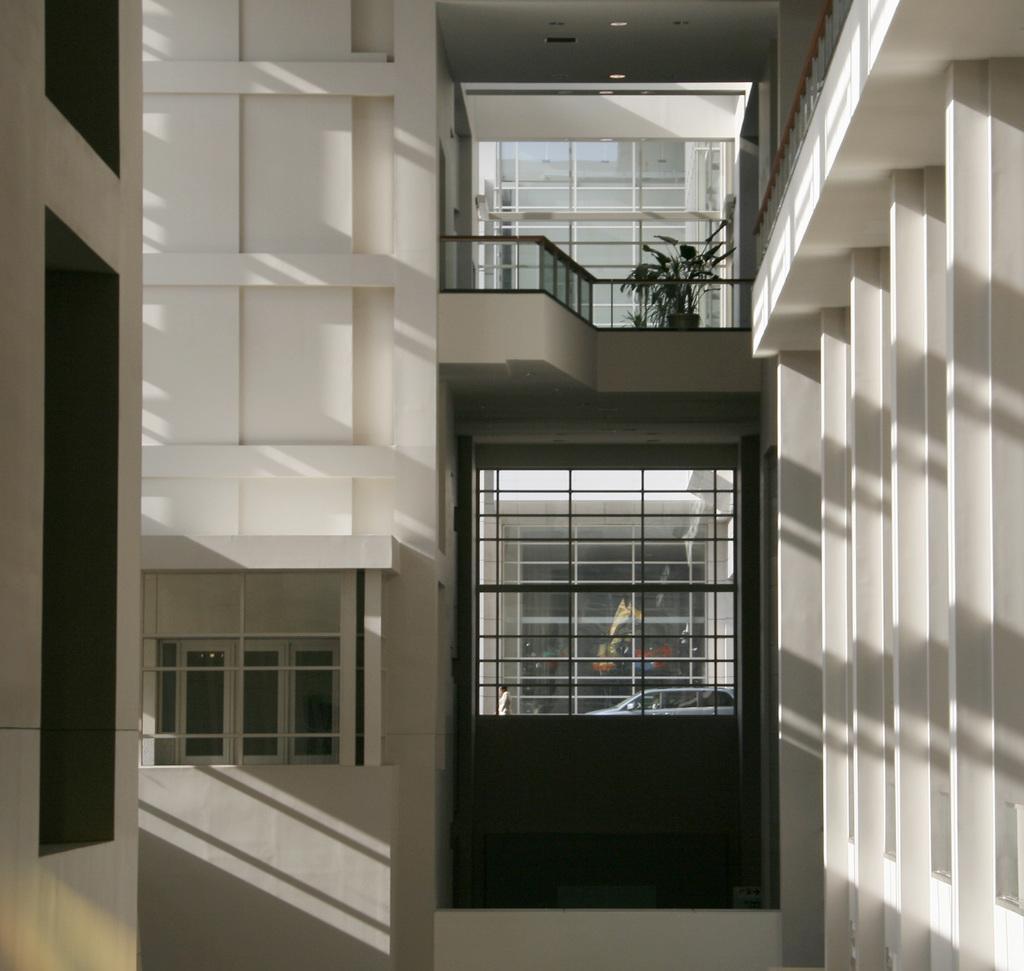Can you describe this image briefly? In the foreground of this image, there are walls of a building and we can also see glass windows, railing and a plant. 